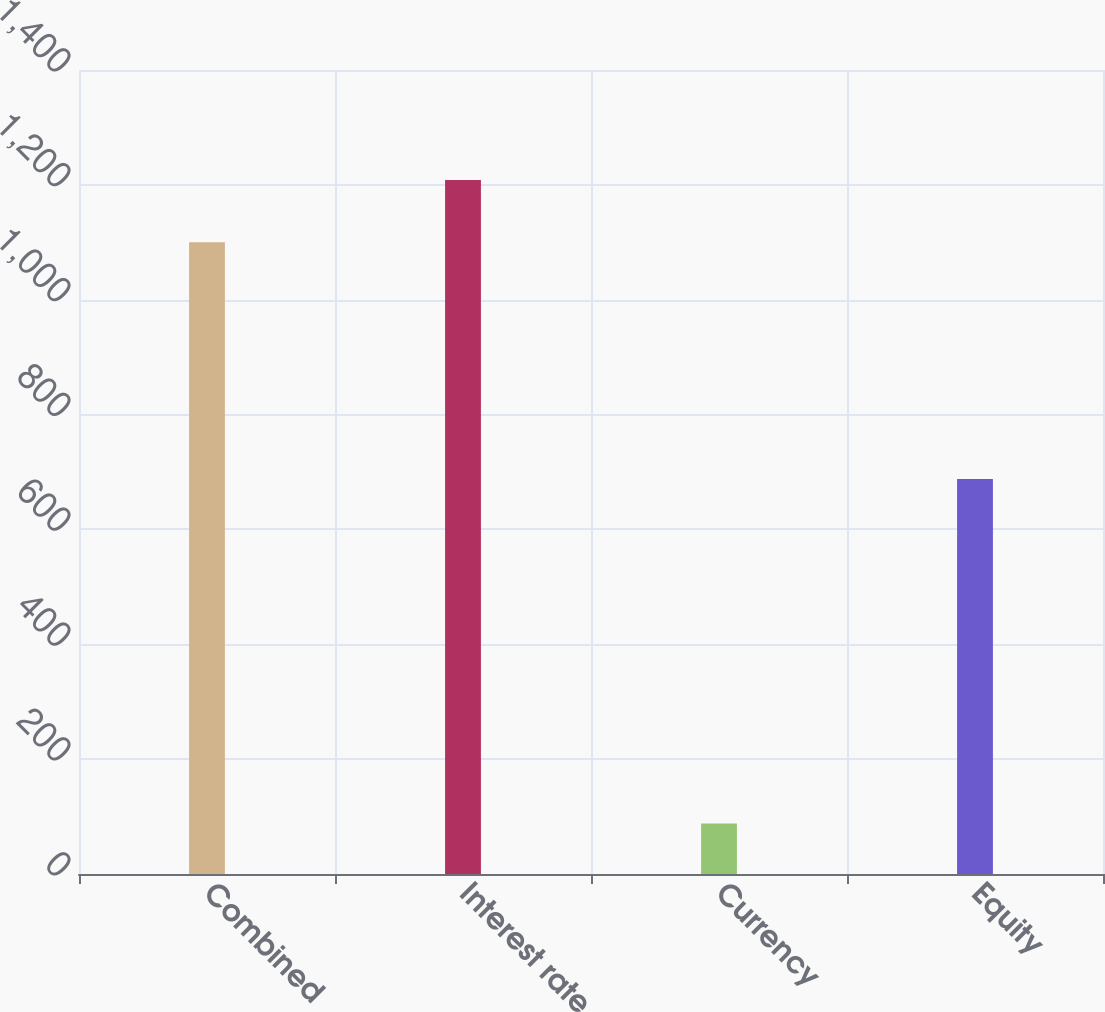Convert chart to OTSL. <chart><loc_0><loc_0><loc_500><loc_500><bar_chart><fcel>Combined<fcel>Interest rate<fcel>Currency<fcel>Equity<nl><fcel>1100<fcel>1208.5<fcel>88<fcel>688<nl></chart> 